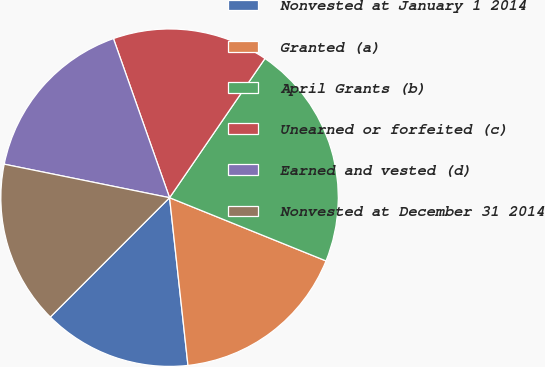Convert chart. <chart><loc_0><loc_0><loc_500><loc_500><pie_chart><fcel>Nonvested at January 1 2014<fcel>Granted (a)<fcel>April Grants (b)<fcel>Unearned or forfeited (c)<fcel>Earned and vested (d)<fcel>Nonvested at December 31 2014<nl><fcel>14.23%<fcel>17.15%<fcel>21.55%<fcel>14.96%<fcel>16.42%<fcel>15.69%<nl></chart> 